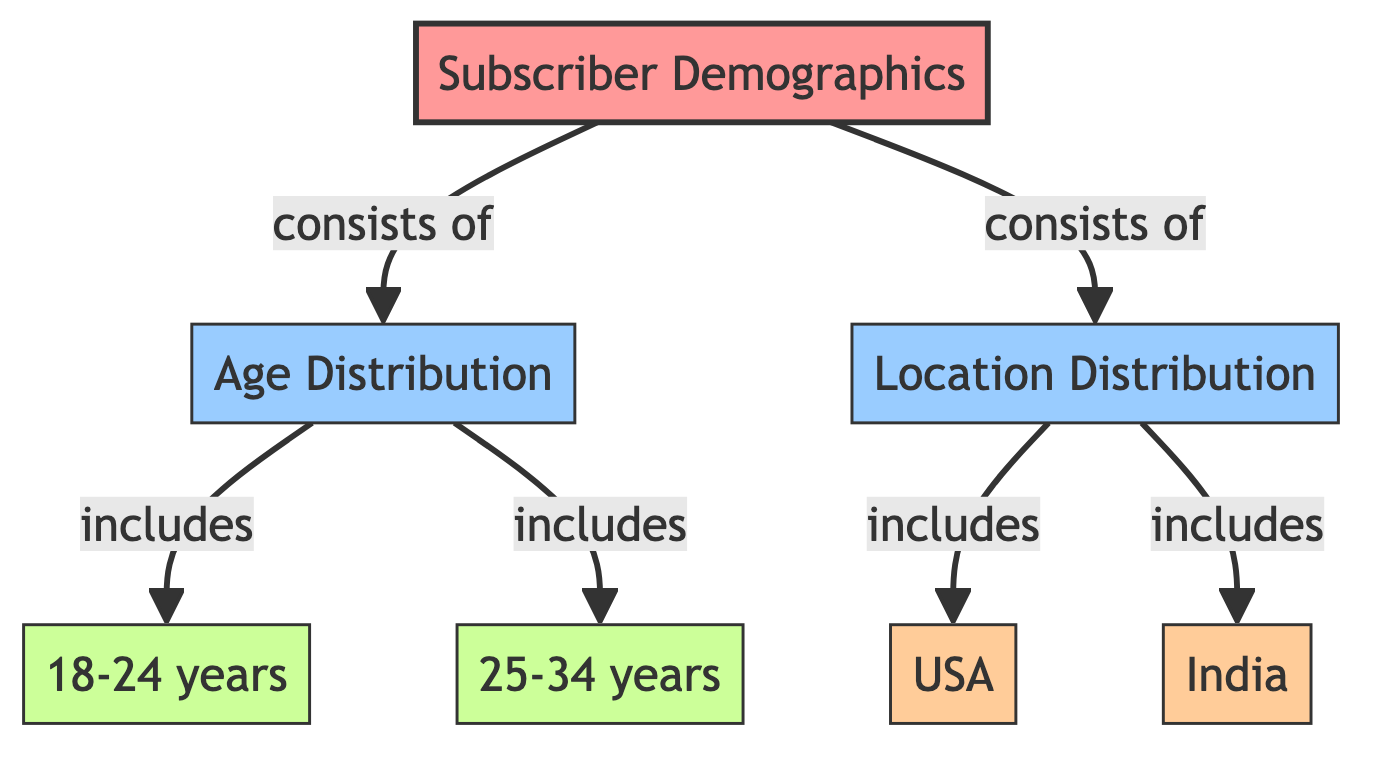What are the two main categories in the diagram? The diagram has two main categories: Age Distribution and Location Distribution, as denoted by the connections from the root node Subscriber Demographics.
Answer: Age Distribution, Location Distribution How many age groups are included in the Age Distribution category? The Age Distribution category includes two age groups: 18-24 years and 25-34 years, which can be determined by counting the nodes that fall under the Age Distribution category.
Answer: 2 Which location is specifically mentioned in the diagram? The diagram specifically mentions two locations: USA and India, as indicated in the Location Distribution category.
Answer: USA, India What is the relationship between Subscriber Demographics and Age Distribution? The relationship is that Subscriber Demographics consists of Age Distribution, which is shown through the directional arrow from the Subscriber Demographics node to the Age Distribution node.
Answer: consists of What nodes are linked to the Age Distribution category? The Age Distribution category has two linked nodes: 18-24 years and 25-34 years, as these are explicitly defined under the Age Distribution category in the diagram.
Answer: 18-24 years, 25-34 years How many nodes are there under the Location Distribution category? The Location Distribution category has two nodes associated with it, specifically USA and India, which can be counted from the links under that category.
Answer: 2 What does the diagram suggest about the structure of Subscriber Demographics? The structure suggests that Subscriber Demographics is a comprehensive overview that includes both Age Distribution and Location Distribution as its main components.
Answer: overview of Age and Location How are the main categories in the diagram visually differentiated? The main categories are visually differentiated by using distinct colors and styles, with Age Distribution in blue and Location Distribution in light orange, helping to differentiate their roles within the diagram.
Answer: colors and styles What is the significance of the linking style used in the diagram? The linking style, which includes a stroke width of 2 pixels and a uniform stroke color, emphasizes the relationships and connections among the nodes, making it easier to follow the flow of information throughout the diagram.
Answer: emphasizes relationships 